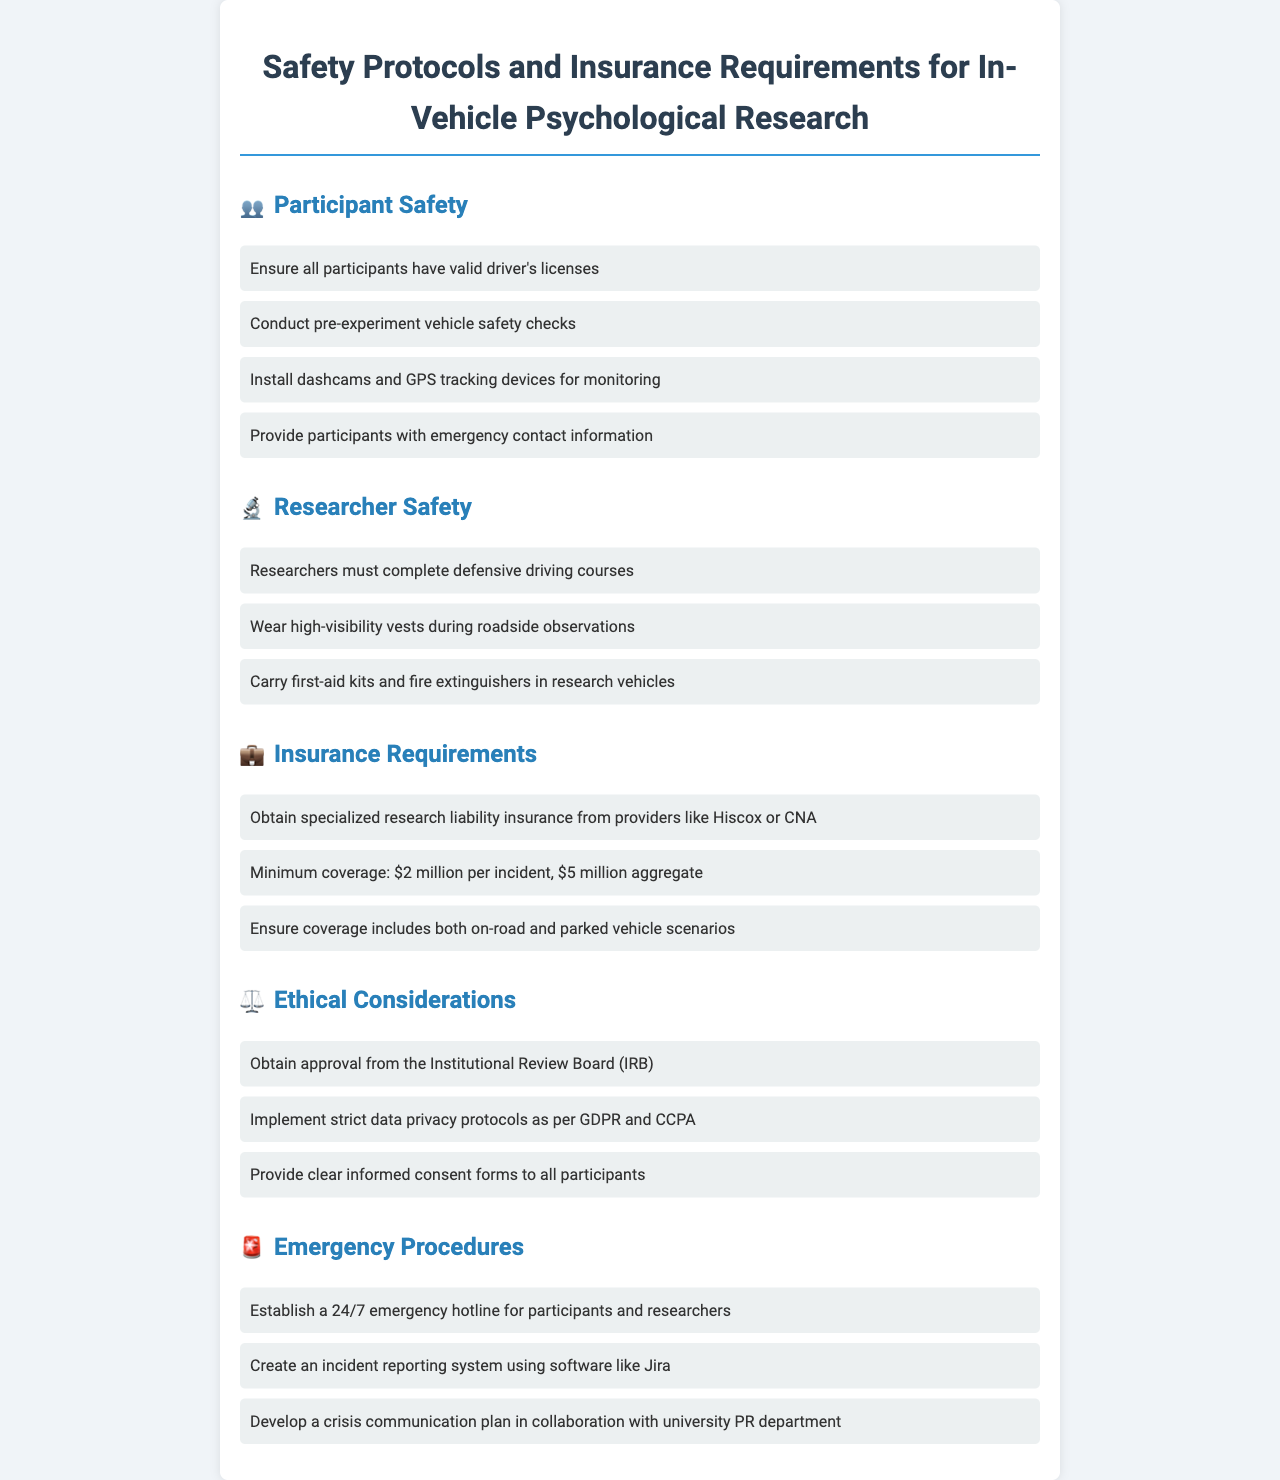What is the minimum coverage required for insurance? The document states that the minimum coverage required is specified for research liability insurance, which is $2 million per incident, $5 million aggregate.
Answer: $2 million per incident, $5 million aggregate What must researchers complete before conducting roadside observations? According to the safety protocols, researchers must complete defensive driving courses.
Answer: Defensive driving courses What emergency equipment must researchers carry in research vehicles? The document specifies that researchers should carry first-aid kits and fire extinguishers in research vehicles for safety.
Answer: First-aid kits and fire extinguishers What is required for participant safety during the experiment? The safety protocol requires that all participants have valid driver's licenses as part of ensuring participant safety during the experiment.
Answer: Valid driver's licenses Which organization must approve the research protocol? The document mentions that the research protocol must be approved by the Institutional Review Board (IRB) to ensure ethical considerations are met.
Answer: Institutional Review Board (IRB) What tracking devices should be installed in vehicles? The safety protocols state that dashcams and GPS tracking devices should be installed for monitoring during the in-vehicle research.
Answer: Dashcams and GPS tracking devices How should participants be informed of emergency contacts? The document indicates that participants should be provided with emergency contact information as part of participant safety measures.
Answer: Emergency contact information What software can be used for the incident reporting system? The document suggests using software like Jira to create an incident reporting system for safety management.
Answer: Jira What kind of privacy regulations must be implemented? The document specifies that strict data privacy protocols must be implemented as per GDPR and CCPA in relation to ethical considerations.
Answer: GDPR and CCPA 